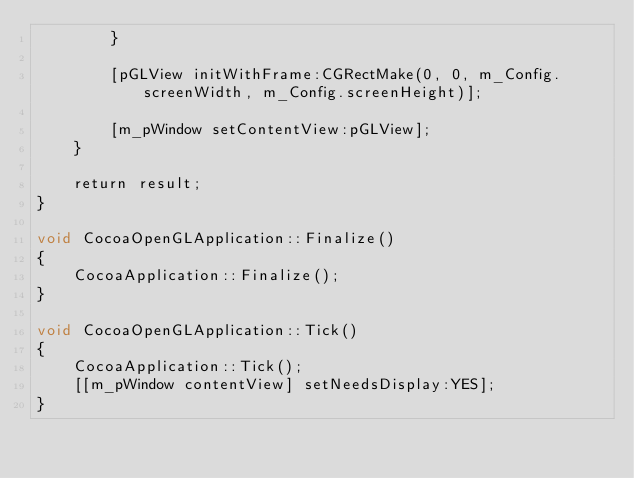<code> <loc_0><loc_0><loc_500><loc_500><_ObjectiveC_>        }

        [pGLView initWithFrame:CGRectMake(0, 0, m_Config.screenWidth, m_Config.screenHeight)];

        [m_pWindow setContentView:pGLView];
    }

    return result;
}

void CocoaOpenGLApplication::Finalize()
{
    CocoaApplication::Finalize();
}

void CocoaOpenGLApplication::Tick()
{
    CocoaApplication::Tick();
    [[m_pWindow contentView] setNeedsDisplay:YES];
}

</code> 